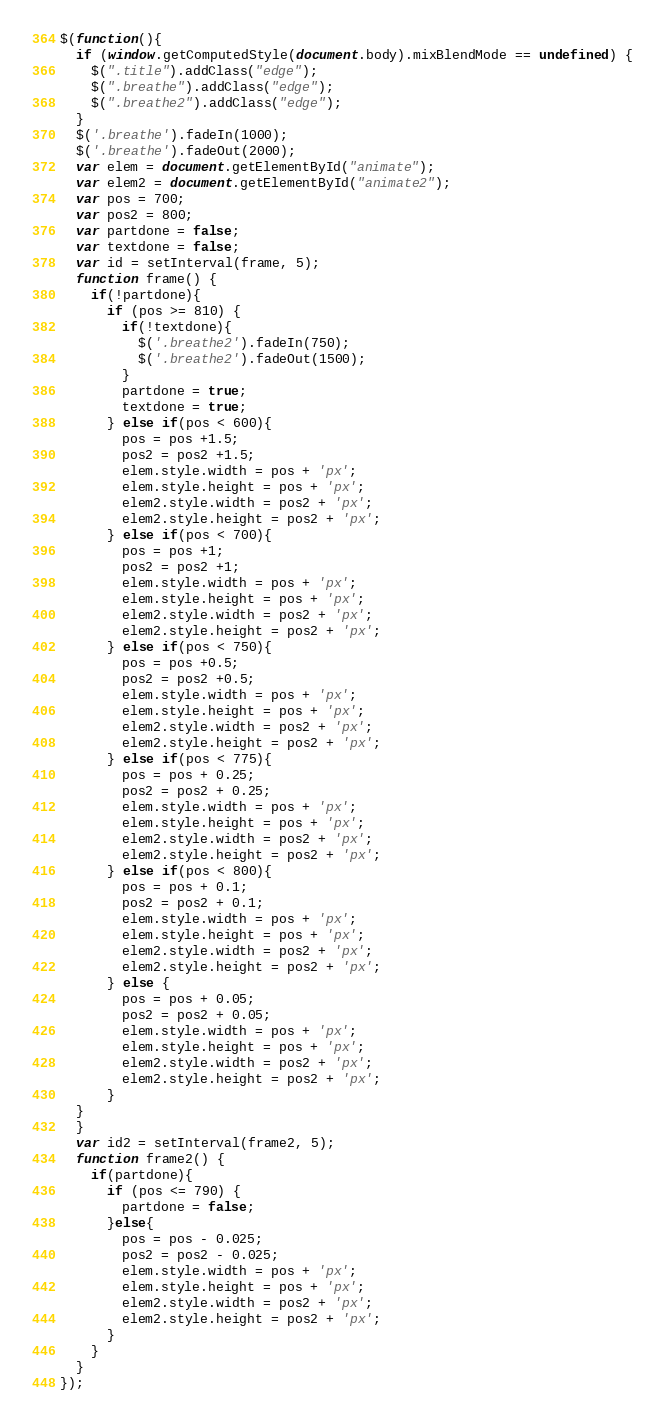<code> <loc_0><loc_0><loc_500><loc_500><_JavaScript_>$(function(){
  if (window.getComputedStyle(document.body).mixBlendMode == undefined) {
    $(".title").addClass("edge");
    $(".breathe").addClass("edge");
    $(".breathe2").addClass("edge");
  }
  $('.breathe').fadeIn(1000);
  $('.breathe').fadeOut(2000);
  var elem = document.getElementById("animate");
  var elem2 = document.getElementById("animate2"); 
  var pos = 700;
  var pos2 = 800;
  var partdone = false;
  var textdone = false;
  var id = setInterval(frame, 5);
  function frame() {
    if(!partdone){
      if (pos >= 810) {
        if(!textdone){
          $('.breathe2').fadeIn(750);
          $('.breathe2').fadeOut(1500);
        }
        partdone = true;
        textdone = true;
      } else if(pos < 600){
        pos = pos +1.5; 
        pos2 = pos2 +1.5;
        elem.style.width = pos + 'px'; 
        elem.style.height = pos + 'px';
        elem2.style.width = pos2 + 'px'; 
        elem2.style.height = pos2 + 'px'; 
      } else if(pos < 700){
        pos = pos +1; 
        pos2 = pos2 +1; 
        elem.style.width = pos + 'px'; 
        elem.style.height = pos + 'px'; 
        elem2.style.width = pos2 + 'px'; 
        elem2.style.height = pos2 + 'px'; 
      } else if(pos < 750){
        pos = pos +0.5; 
        pos2 = pos2 +0.5; 
        elem.style.width = pos + 'px'; 
        elem.style.height = pos + 'px'; 
        elem2.style.width = pos2 + 'px'; 
        elem2.style.height = pos2 + 'px'; 
      } else if(pos < 775){
        pos = pos + 0.25; 
        pos2 = pos2 + 0.25; 
        elem.style.width = pos + 'px'; 
        elem.style.height = pos + 'px'; 
        elem2.style.width = pos2 + 'px'; 
        elem2.style.height = pos2 + 'px'; 
      } else if(pos < 800){
        pos = pos + 0.1; 
        pos2 = pos2 + 0.1;
        elem.style.width = pos + 'px'; 
        elem.style.height = pos + 'px'; 
        elem2.style.width = pos2 + 'px'; 
        elem2.style.height = pos2 + 'px'; 
      } else {
        pos = pos + 0.05; 
        pos2 = pos2 + 0.05;
        elem.style.width = pos + 'px'; 
        elem.style.height = pos + 'px'; 
        elem2.style.width = pos2 + 'px'; 
        elem2.style.height = pos2 + 'px'; 
      } 
  }
  }
  var id2 = setInterval(frame2, 5);
  function frame2() {
    if(partdone){
      if (pos <= 790) {
        partdone = false;
      }else{
        pos = pos - 0.025; 
        pos2 = pos2 - 0.025;
        elem.style.width = pos + 'px'; 
        elem.style.height = pos + 'px'; 
        elem2.style.width = pos2 + 'px'; 
        elem2.style.height = pos2 + 'px'; 
      }
    }
  }
});</code> 